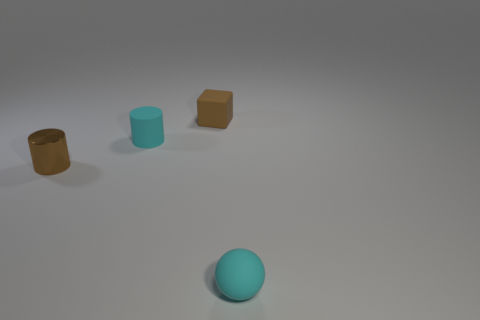Add 2 small brown metal cylinders. How many objects exist? 6 Subtract 1 balls. How many balls are left? 0 Subtract all spheres. How many objects are left? 3 Add 4 small objects. How many small objects exist? 8 Subtract 0 brown balls. How many objects are left? 4 Subtract all gray cylinders. Subtract all blue blocks. How many cylinders are left? 2 Subtract all yellow cylinders. How many yellow balls are left? 0 Subtract all brown rubber blocks. Subtract all purple metal cubes. How many objects are left? 3 Add 2 cyan rubber things. How many cyan rubber things are left? 4 